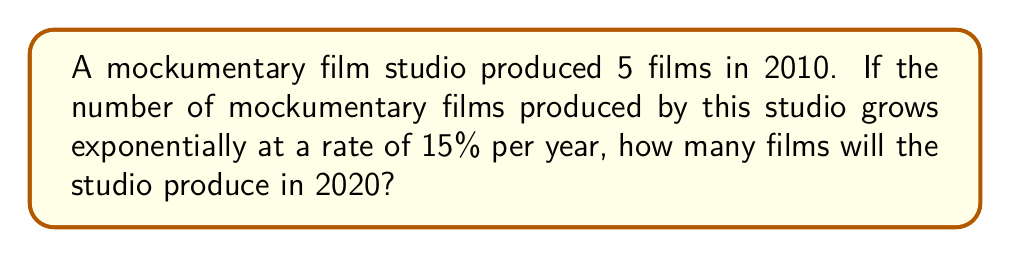Teach me how to tackle this problem. To solve this problem, we'll use the exponential growth formula:

$$A = P(1 + r)^t$$

Where:
$A$ = Final amount
$P$ = Initial amount
$r$ = Growth rate (as a decimal)
$t$ = Time period

Given:
$P = 5$ (initial number of films in 2010)
$r = 0.15$ (15% growth rate)
$t = 10$ (years from 2010 to 2020)

Let's substitute these values into the formula:

$$A = 5(1 + 0.15)^{10}$$

Now, let's solve step-by-step:

1) First, calculate $(1 + 0.15)$:
   $$(1 + 0.15) = 1.15$$

2) Now, our equation looks like this:
   $$A = 5(1.15)^{10}$$

3) Calculate $1.15^{10}$:
   $$1.15^{10} \approx 4.0456$$

4) Finally, multiply by 5:
   $$A = 5 \times 4.0456 \approx 20.228$$

5) Since we can't produce a fraction of a film, we round to the nearest whole number:
   $$A \approx 20$$

Therefore, the studio will produce approximately 20 mockumentary films in 2020.
Answer: 20 films 